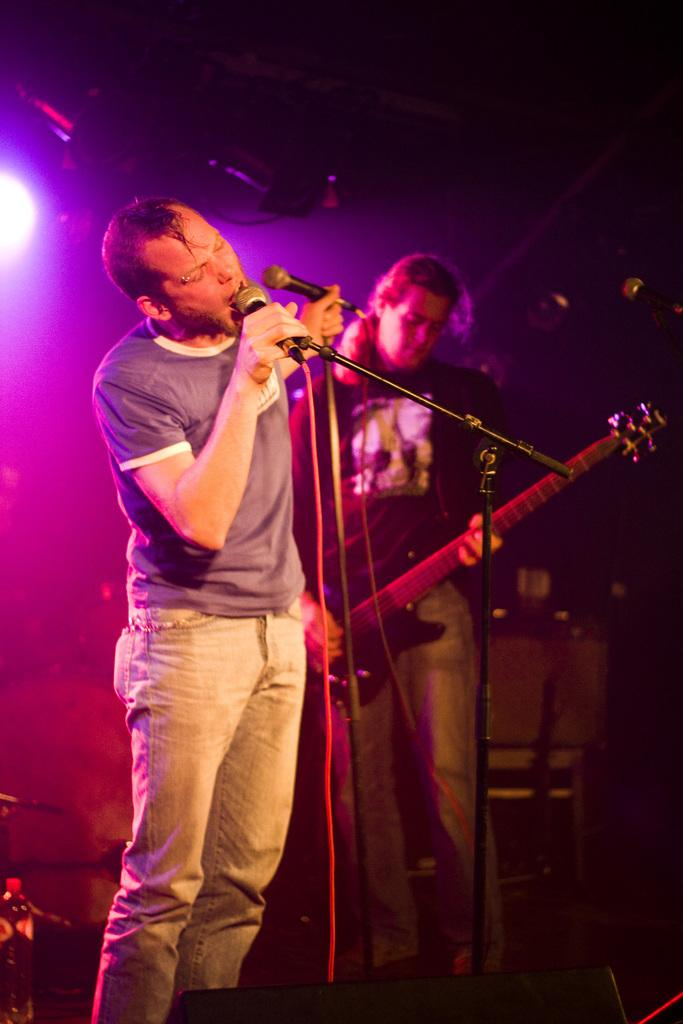What is the man in the image doing? The man is singing in the image. How is the man amplifying his voice while singing? The man is using a microphone in the image. What musical instrument is the man playing? The man is playing a guitar in the image. What type of air is being used to power the guitar in the image? There is no air or any power source mentioned for the guitar in the image; it is being played acoustically. 